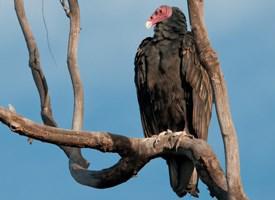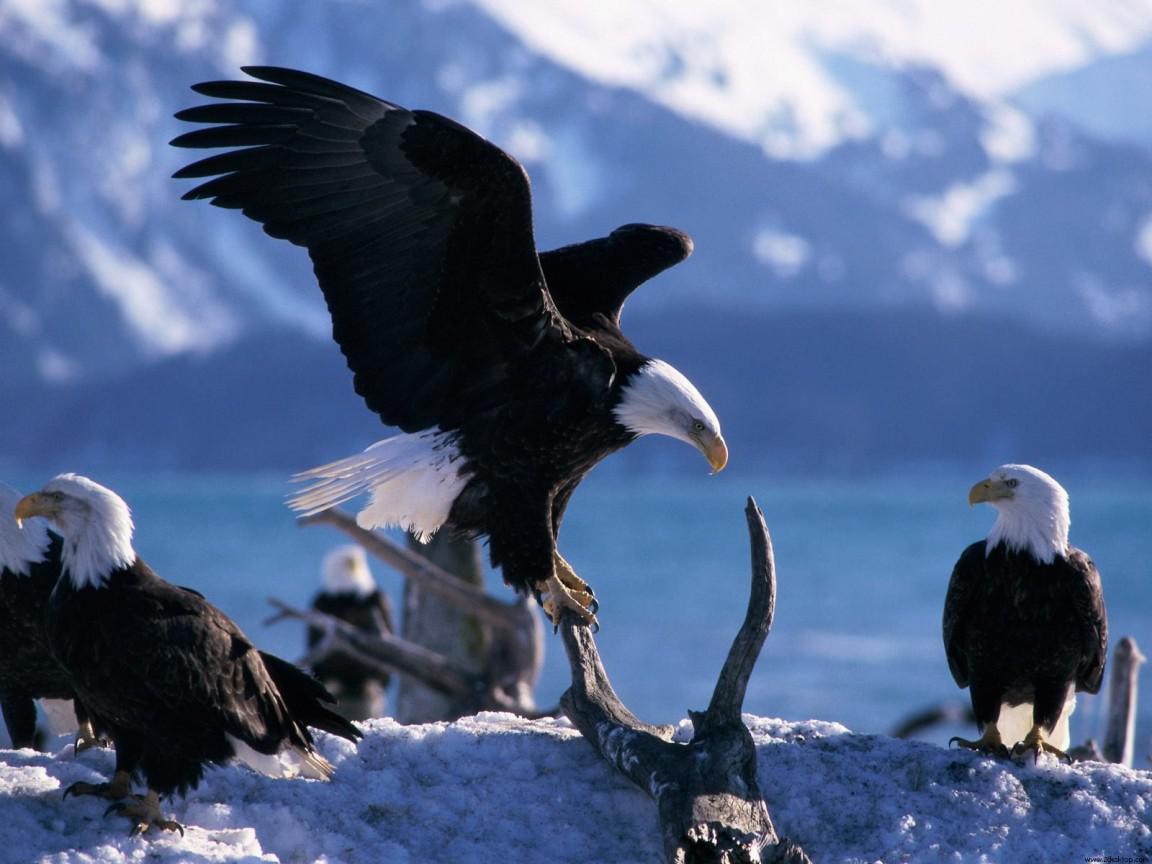The first image is the image on the left, the second image is the image on the right. For the images displayed, is the sentence "One of the images shows exactly one bald eagle with wings spread." factually correct? Answer yes or no. Yes. 